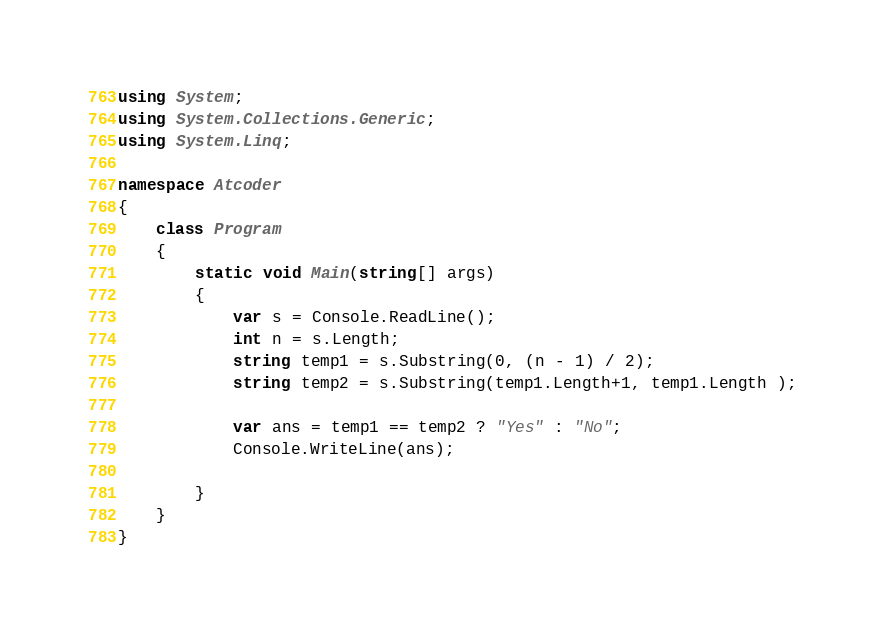Convert code to text. <code><loc_0><loc_0><loc_500><loc_500><_C#_>using System;
using System.Collections.Generic;
using System.Linq;

namespace Atcoder
{
    class Program
    {
        static void Main(string[] args)
        {
            var s = Console.ReadLine();
            int n = s.Length;
            string temp1 = s.Substring(0, (n - 1) / 2);
            string temp2 = s.Substring(temp1.Length+1, temp1.Length );

            var ans = temp1 == temp2 ? "Yes" : "No";
            Console.WriteLine(ans);

        }
    }
}
</code> 